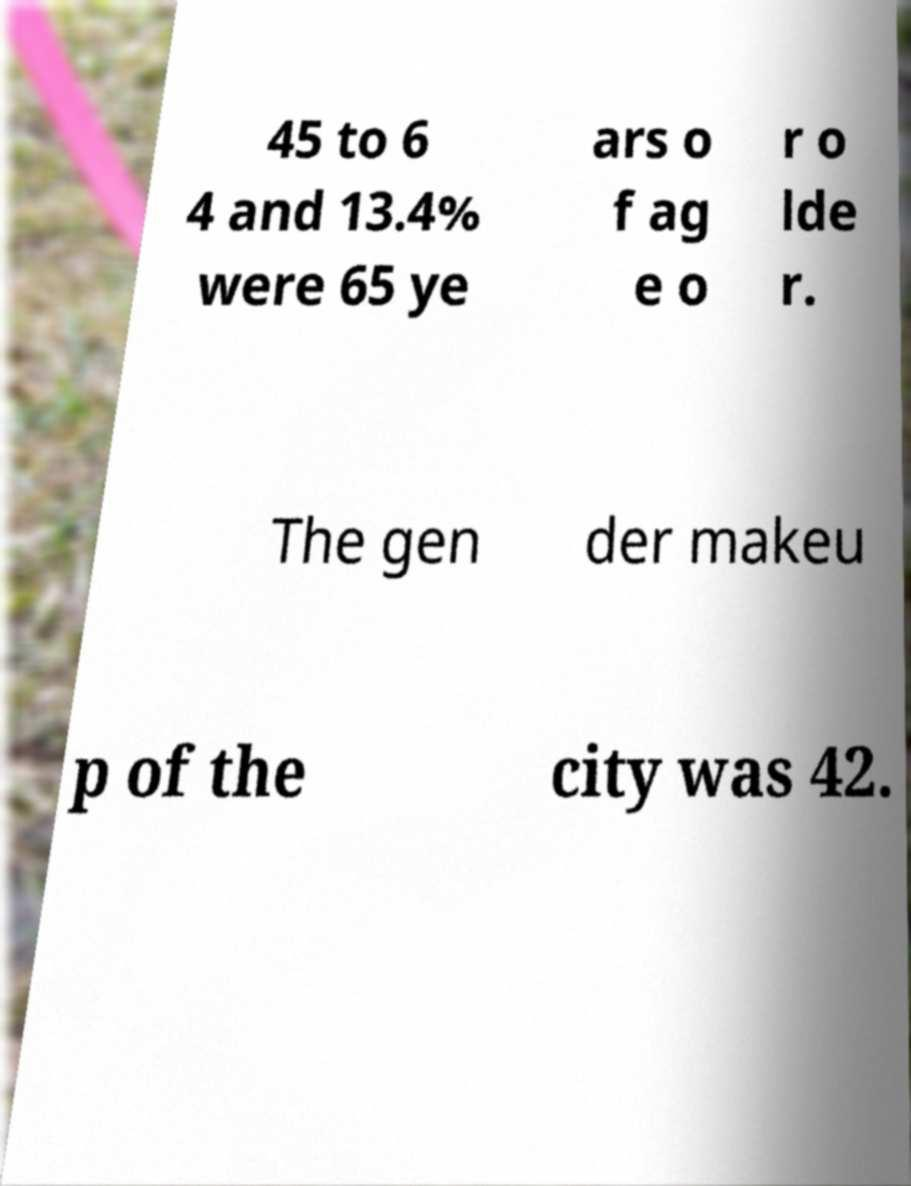Please identify and transcribe the text found in this image. 45 to 6 4 and 13.4% were 65 ye ars o f ag e o r o lde r. The gen der makeu p of the city was 42. 